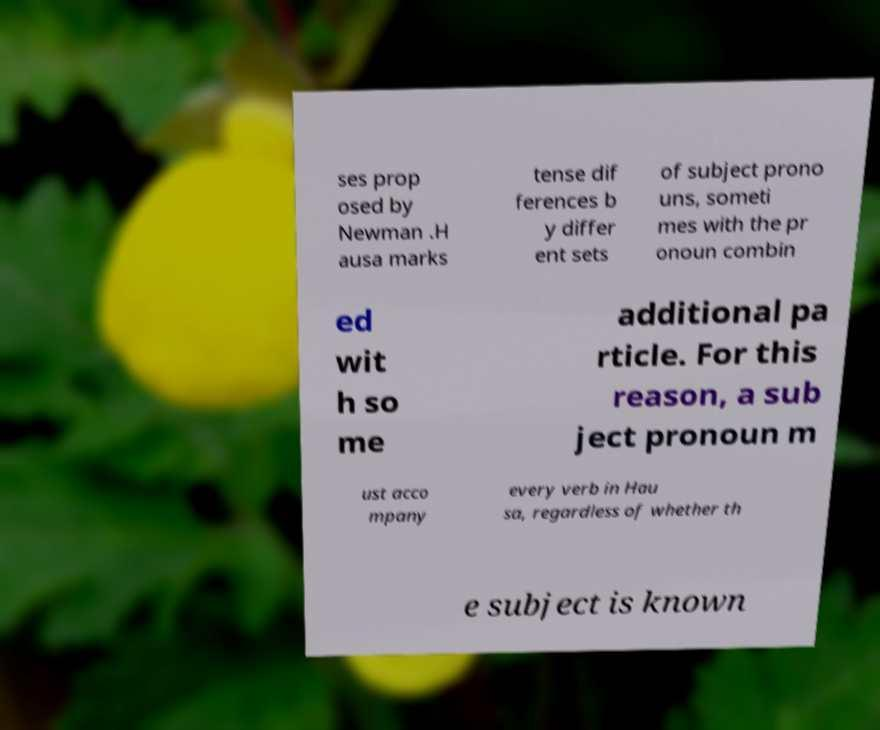I need the written content from this picture converted into text. Can you do that? ses prop osed by Newman .H ausa marks tense dif ferences b y differ ent sets of subject prono uns, someti mes with the pr onoun combin ed wit h so me additional pa rticle. For this reason, a sub ject pronoun m ust acco mpany every verb in Hau sa, regardless of whether th e subject is known 